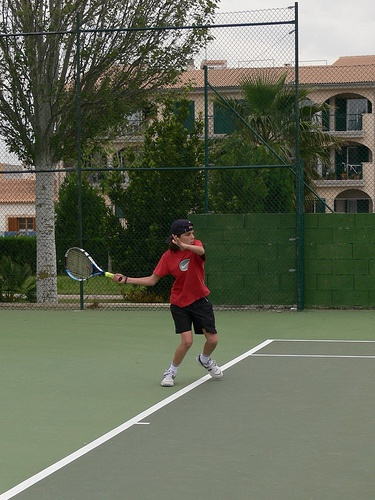Describe the objects in this image and their specific colors. I can see people in darkgray, black, maroon, gray, and brown tones and tennis racket in darkgray, gray, darkgreen, black, and white tones in this image. 